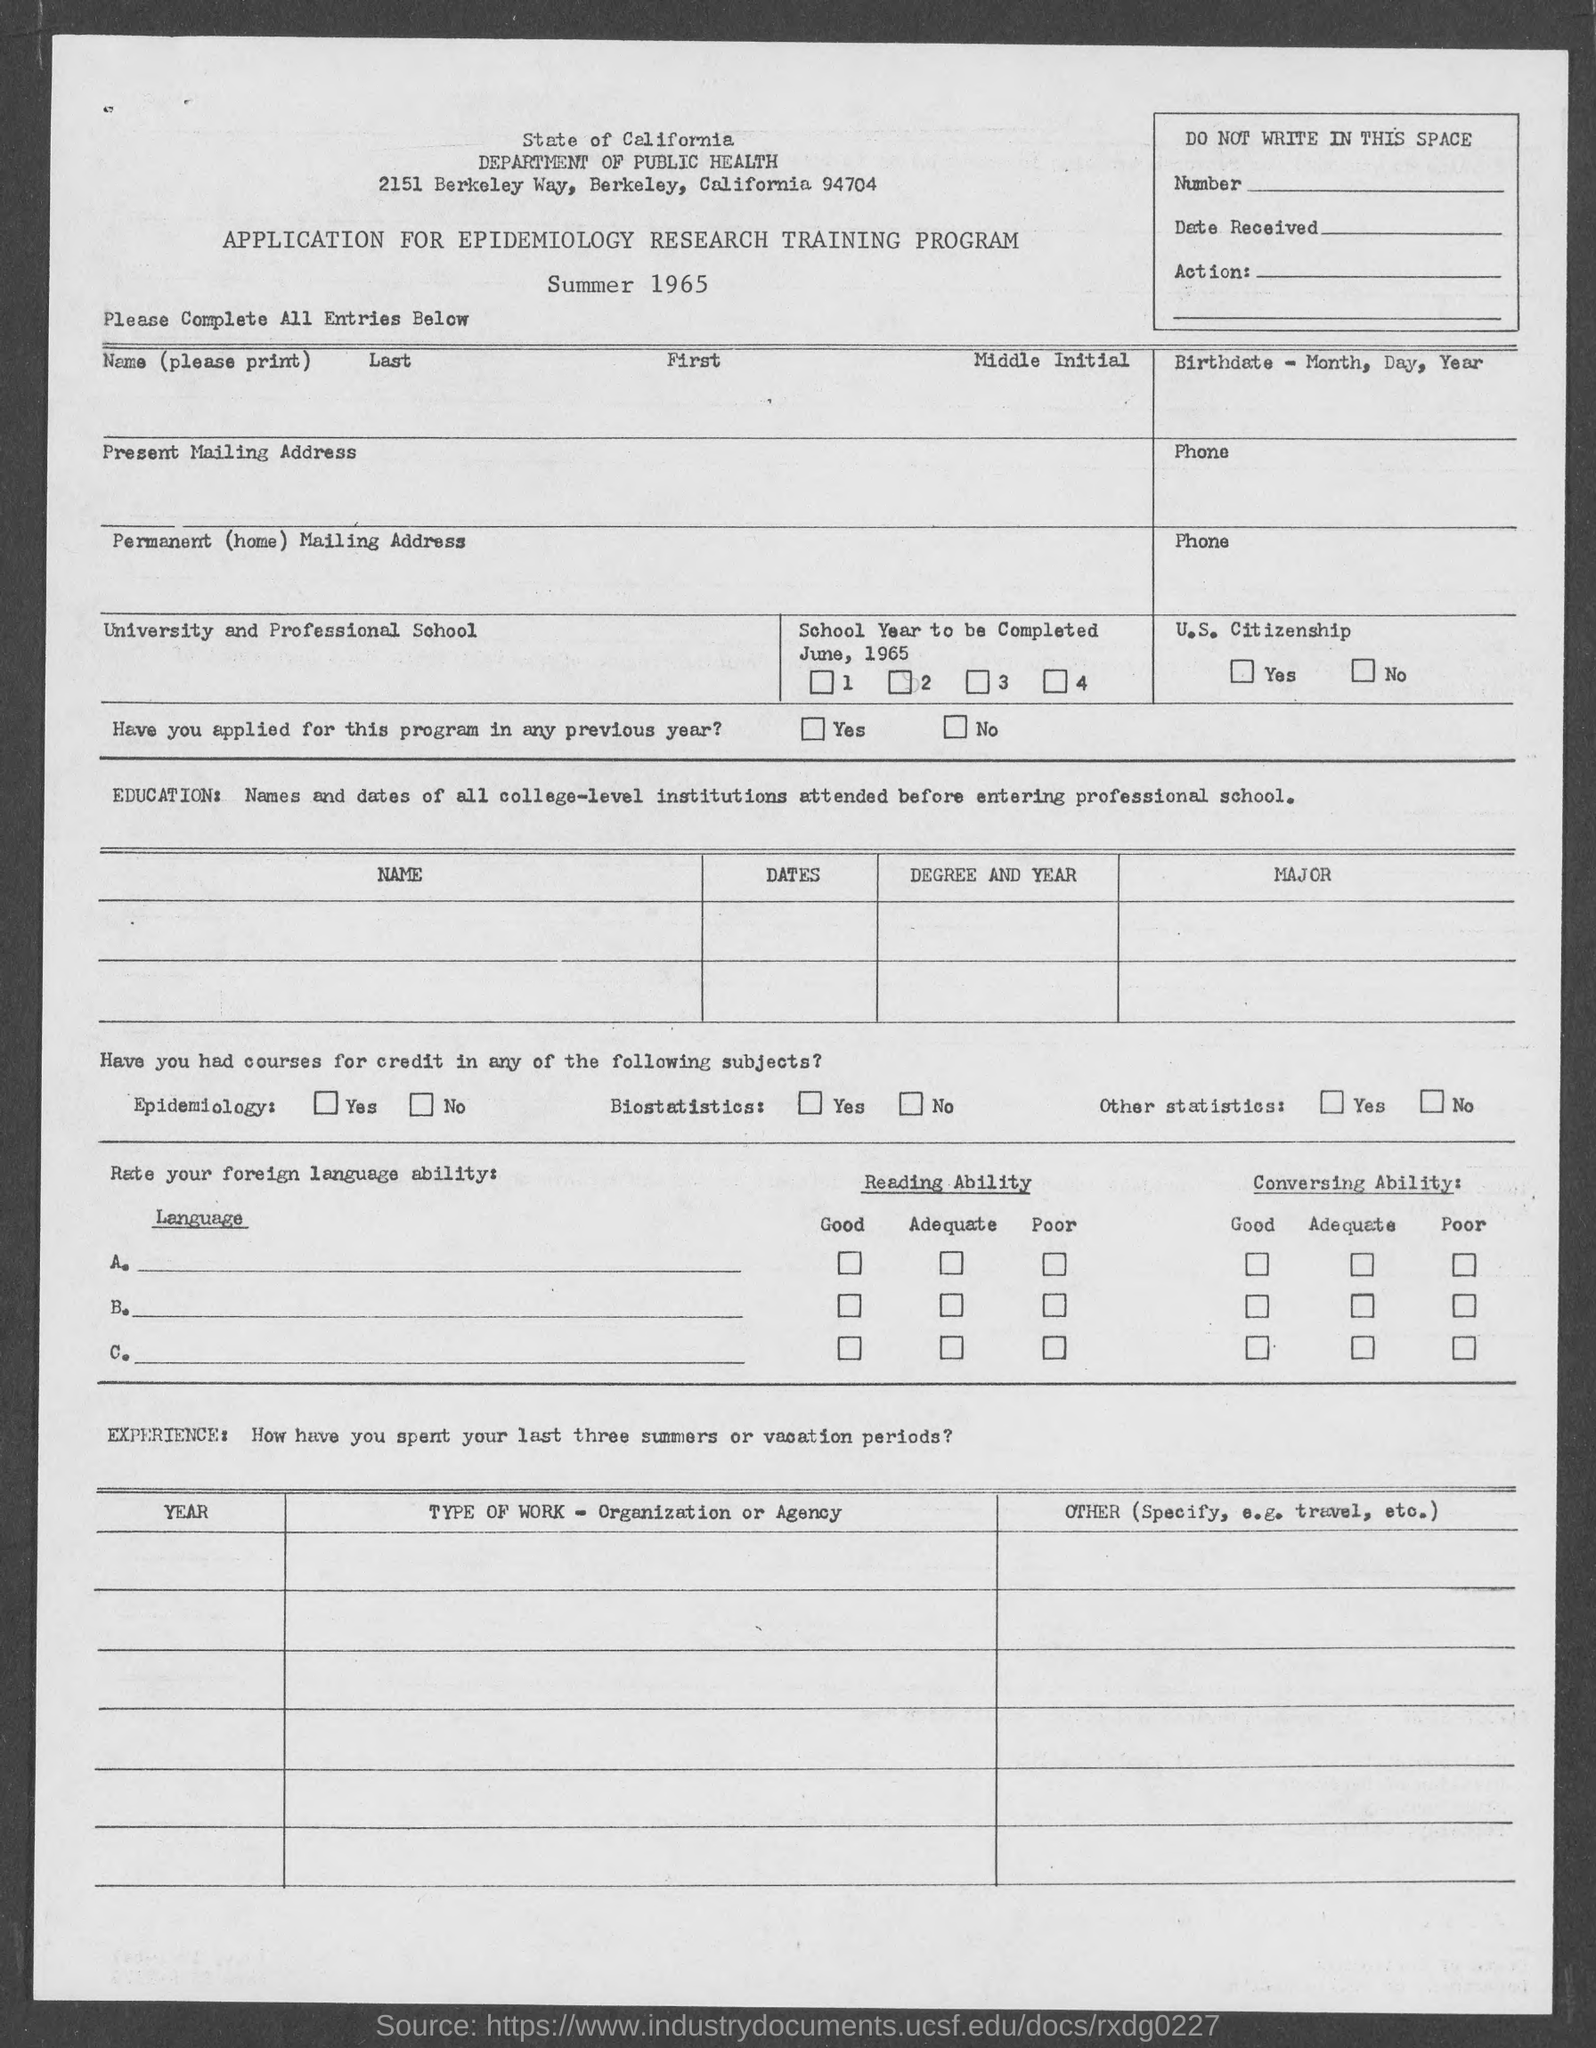Outline some significant characteristics in this image. The State of California Department of Public Health is located in the city where 2151 Berkeley Way can be found. 